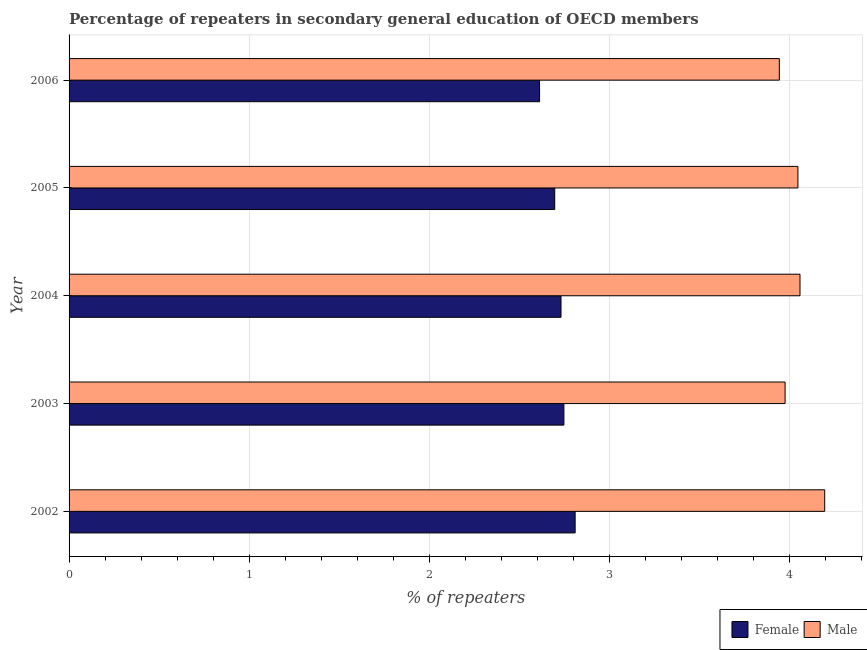How many bars are there on the 1st tick from the bottom?
Ensure brevity in your answer.  2. In how many cases, is the number of bars for a given year not equal to the number of legend labels?
Your response must be concise. 0. What is the percentage of male repeaters in 2004?
Provide a short and direct response. 4.06. Across all years, what is the maximum percentage of male repeaters?
Ensure brevity in your answer.  4.19. Across all years, what is the minimum percentage of female repeaters?
Make the answer very short. 2.61. What is the total percentage of female repeaters in the graph?
Make the answer very short. 13.6. What is the difference between the percentage of male repeaters in 2004 and that in 2005?
Offer a very short reply. 0.01. What is the difference between the percentage of female repeaters in 2002 and the percentage of male repeaters in 2004?
Provide a short and direct response. -1.25. What is the average percentage of male repeaters per year?
Offer a terse response. 4.04. In the year 2005, what is the difference between the percentage of male repeaters and percentage of female repeaters?
Your answer should be very brief. 1.35. In how many years, is the percentage of male repeaters greater than 1.2 %?
Keep it short and to the point. 5. What is the ratio of the percentage of male repeaters in 2003 to that in 2004?
Offer a very short reply. 0.98. Is the difference between the percentage of female repeaters in 2005 and 2006 greater than the difference between the percentage of male repeaters in 2005 and 2006?
Offer a terse response. No. What is the difference between the highest and the second highest percentage of female repeaters?
Your answer should be compact. 0.06. What is the difference between the highest and the lowest percentage of female repeaters?
Make the answer very short. 0.2. What does the 1st bar from the top in 2004 represents?
Your answer should be compact. Male. How many bars are there?
Offer a terse response. 10. How many years are there in the graph?
Provide a short and direct response. 5. Are the values on the major ticks of X-axis written in scientific E-notation?
Give a very brief answer. No. Does the graph contain grids?
Offer a very short reply. Yes. How are the legend labels stacked?
Provide a succinct answer. Horizontal. What is the title of the graph?
Keep it short and to the point. Percentage of repeaters in secondary general education of OECD members. Does "Forest" appear as one of the legend labels in the graph?
Give a very brief answer. No. What is the label or title of the X-axis?
Your answer should be compact. % of repeaters. What is the label or title of the Y-axis?
Give a very brief answer. Year. What is the % of repeaters of Female in 2002?
Provide a short and direct response. 2.81. What is the % of repeaters of Male in 2002?
Provide a short and direct response. 4.19. What is the % of repeaters of Female in 2003?
Your answer should be very brief. 2.75. What is the % of repeaters of Male in 2003?
Provide a succinct answer. 3.97. What is the % of repeaters of Female in 2004?
Offer a terse response. 2.73. What is the % of repeaters of Male in 2004?
Your answer should be compact. 4.06. What is the % of repeaters in Female in 2005?
Give a very brief answer. 2.7. What is the % of repeaters of Male in 2005?
Provide a short and direct response. 4.05. What is the % of repeaters of Female in 2006?
Provide a succinct answer. 2.61. What is the % of repeaters in Male in 2006?
Provide a succinct answer. 3.94. Across all years, what is the maximum % of repeaters in Female?
Make the answer very short. 2.81. Across all years, what is the maximum % of repeaters of Male?
Make the answer very short. 4.19. Across all years, what is the minimum % of repeaters in Female?
Your answer should be very brief. 2.61. Across all years, what is the minimum % of repeaters of Male?
Provide a succinct answer. 3.94. What is the total % of repeaters in Female in the graph?
Your response must be concise. 13.6. What is the total % of repeaters in Male in the graph?
Your response must be concise. 20.22. What is the difference between the % of repeaters of Female in 2002 and that in 2003?
Give a very brief answer. 0.06. What is the difference between the % of repeaters in Male in 2002 and that in 2003?
Provide a succinct answer. 0.22. What is the difference between the % of repeaters of Female in 2002 and that in 2004?
Provide a succinct answer. 0.08. What is the difference between the % of repeaters of Male in 2002 and that in 2004?
Offer a very short reply. 0.14. What is the difference between the % of repeaters of Female in 2002 and that in 2005?
Give a very brief answer. 0.11. What is the difference between the % of repeaters of Male in 2002 and that in 2005?
Your response must be concise. 0.15. What is the difference between the % of repeaters of Female in 2002 and that in 2006?
Your answer should be compact. 0.2. What is the difference between the % of repeaters of Male in 2002 and that in 2006?
Keep it short and to the point. 0.25. What is the difference between the % of repeaters in Female in 2003 and that in 2004?
Offer a very short reply. 0.02. What is the difference between the % of repeaters in Male in 2003 and that in 2004?
Keep it short and to the point. -0.08. What is the difference between the % of repeaters in Female in 2003 and that in 2005?
Your answer should be compact. 0.05. What is the difference between the % of repeaters of Male in 2003 and that in 2005?
Your answer should be compact. -0.07. What is the difference between the % of repeaters of Female in 2003 and that in 2006?
Make the answer very short. 0.14. What is the difference between the % of repeaters of Male in 2003 and that in 2006?
Provide a short and direct response. 0.03. What is the difference between the % of repeaters in Female in 2004 and that in 2005?
Your response must be concise. 0.03. What is the difference between the % of repeaters of Male in 2004 and that in 2005?
Your response must be concise. 0.01. What is the difference between the % of repeaters in Female in 2004 and that in 2006?
Provide a succinct answer. 0.12. What is the difference between the % of repeaters of Male in 2004 and that in 2006?
Provide a succinct answer. 0.11. What is the difference between the % of repeaters in Female in 2005 and that in 2006?
Offer a very short reply. 0.08. What is the difference between the % of repeaters of Male in 2005 and that in 2006?
Provide a short and direct response. 0.1. What is the difference between the % of repeaters of Female in 2002 and the % of repeaters of Male in 2003?
Make the answer very short. -1.17. What is the difference between the % of repeaters of Female in 2002 and the % of repeaters of Male in 2004?
Offer a terse response. -1.25. What is the difference between the % of repeaters in Female in 2002 and the % of repeaters in Male in 2005?
Give a very brief answer. -1.24. What is the difference between the % of repeaters of Female in 2002 and the % of repeaters of Male in 2006?
Keep it short and to the point. -1.13. What is the difference between the % of repeaters of Female in 2003 and the % of repeaters of Male in 2004?
Make the answer very short. -1.31. What is the difference between the % of repeaters of Female in 2003 and the % of repeaters of Male in 2005?
Ensure brevity in your answer.  -1.3. What is the difference between the % of repeaters of Female in 2003 and the % of repeaters of Male in 2006?
Make the answer very short. -1.2. What is the difference between the % of repeaters of Female in 2004 and the % of repeaters of Male in 2005?
Ensure brevity in your answer.  -1.32. What is the difference between the % of repeaters in Female in 2004 and the % of repeaters in Male in 2006?
Your response must be concise. -1.21. What is the difference between the % of repeaters of Female in 2005 and the % of repeaters of Male in 2006?
Your answer should be very brief. -1.25. What is the average % of repeaters of Female per year?
Your answer should be compact. 2.72. What is the average % of repeaters of Male per year?
Offer a very short reply. 4.04. In the year 2002, what is the difference between the % of repeaters in Female and % of repeaters in Male?
Your answer should be very brief. -1.39. In the year 2003, what is the difference between the % of repeaters of Female and % of repeaters of Male?
Provide a succinct answer. -1.23. In the year 2004, what is the difference between the % of repeaters of Female and % of repeaters of Male?
Ensure brevity in your answer.  -1.33. In the year 2005, what is the difference between the % of repeaters in Female and % of repeaters in Male?
Your answer should be compact. -1.35. In the year 2006, what is the difference between the % of repeaters of Female and % of repeaters of Male?
Offer a very short reply. -1.33. What is the ratio of the % of repeaters in Female in 2002 to that in 2003?
Ensure brevity in your answer.  1.02. What is the ratio of the % of repeaters in Male in 2002 to that in 2003?
Offer a terse response. 1.06. What is the ratio of the % of repeaters in Female in 2002 to that in 2004?
Your answer should be very brief. 1.03. What is the ratio of the % of repeaters of Male in 2002 to that in 2004?
Your answer should be very brief. 1.03. What is the ratio of the % of repeaters in Female in 2002 to that in 2005?
Your response must be concise. 1.04. What is the ratio of the % of repeaters of Male in 2002 to that in 2005?
Provide a short and direct response. 1.04. What is the ratio of the % of repeaters in Female in 2002 to that in 2006?
Ensure brevity in your answer.  1.08. What is the ratio of the % of repeaters of Male in 2002 to that in 2006?
Your answer should be very brief. 1.06. What is the ratio of the % of repeaters of Female in 2003 to that in 2004?
Your response must be concise. 1.01. What is the ratio of the % of repeaters in Male in 2003 to that in 2004?
Offer a terse response. 0.98. What is the ratio of the % of repeaters of Female in 2003 to that in 2005?
Provide a succinct answer. 1.02. What is the ratio of the % of repeaters in Male in 2003 to that in 2005?
Give a very brief answer. 0.98. What is the ratio of the % of repeaters in Female in 2003 to that in 2006?
Ensure brevity in your answer.  1.05. What is the ratio of the % of repeaters in Male in 2003 to that in 2006?
Give a very brief answer. 1.01. What is the ratio of the % of repeaters in Female in 2004 to that in 2005?
Keep it short and to the point. 1.01. What is the ratio of the % of repeaters in Female in 2004 to that in 2006?
Provide a short and direct response. 1.05. What is the ratio of the % of repeaters in Male in 2004 to that in 2006?
Your answer should be compact. 1.03. What is the ratio of the % of repeaters of Female in 2005 to that in 2006?
Offer a very short reply. 1.03. What is the ratio of the % of repeaters of Male in 2005 to that in 2006?
Offer a terse response. 1.03. What is the difference between the highest and the second highest % of repeaters of Female?
Ensure brevity in your answer.  0.06. What is the difference between the highest and the second highest % of repeaters of Male?
Offer a very short reply. 0.14. What is the difference between the highest and the lowest % of repeaters of Female?
Provide a succinct answer. 0.2. What is the difference between the highest and the lowest % of repeaters of Male?
Your answer should be compact. 0.25. 